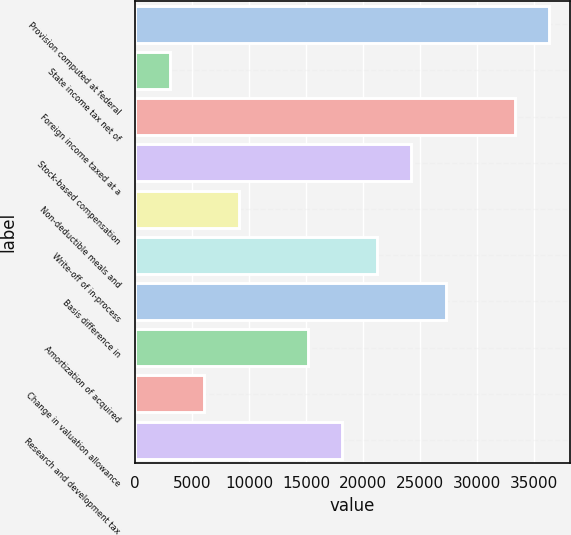<chart> <loc_0><loc_0><loc_500><loc_500><bar_chart><fcel>Provision computed at federal<fcel>State income tax net of<fcel>Foreign income taxed at a<fcel>Stock-based compensation<fcel>Non-deductible meals and<fcel>Write-off of in-process<fcel>Basis difference in<fcel>Amortization of acquired<fcel>Change in valuation allowance<fcel>Research and development tax<nl><fcel>36300.8<fcel>3037.9<fcel>33276.9<fcel>24205.2<fcel>9085.7<fcel>21181.3<fcel>27229.1<fcel>15133.5<fcel>6061.8<fcel>18157.4<nl></chart> 